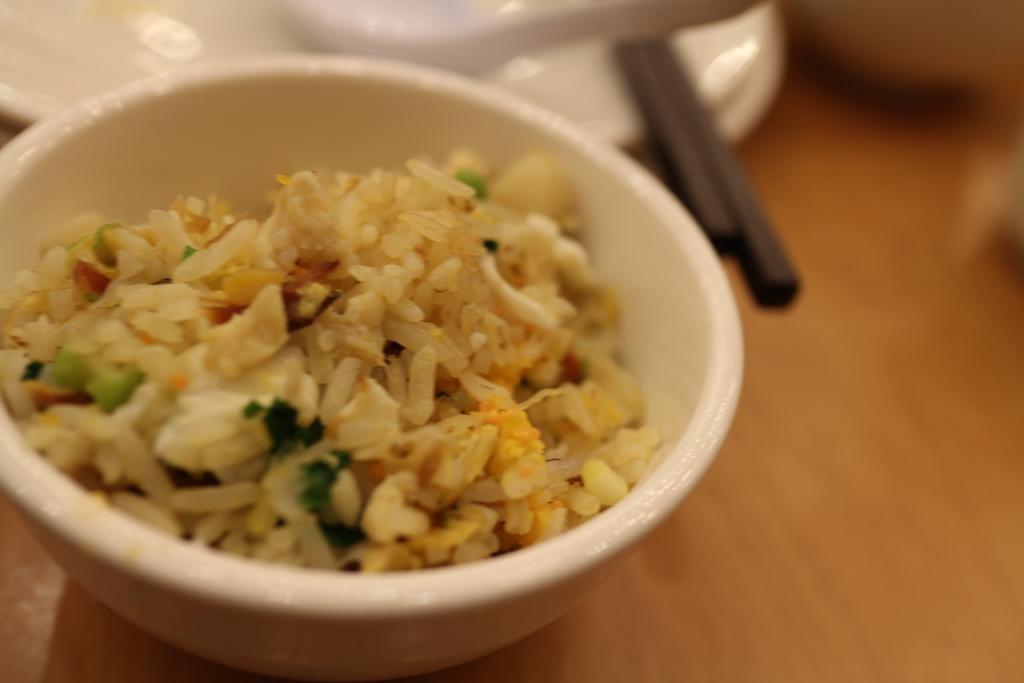Could you give a brief overview of what you see in this image? The picture consists of a table, on the table there are chopsticks, plates, spoons and a bowl of rice. 